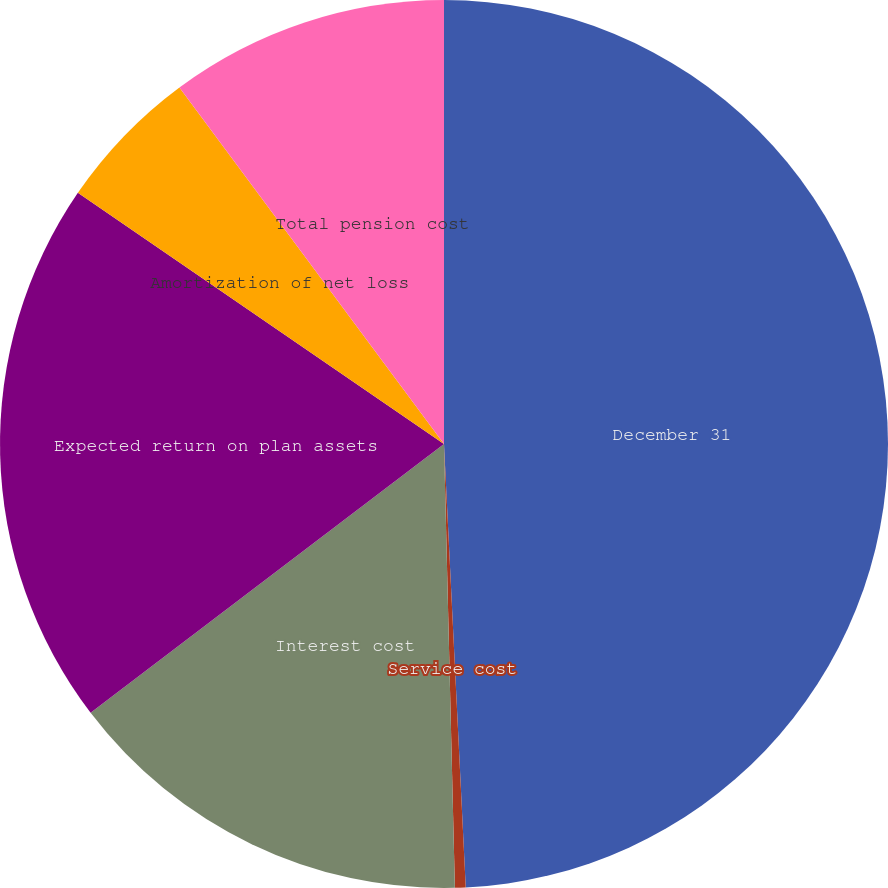Convert chart to OTSL. <chart><loc_0><loc_0><loc_500><loc_500><pie_chart><fcel>December 31<fcel>Service cost<fcel>Interest cost<fcel>Expected return on plan assets<fcel>Amortization of net loss<fcel>Total pension cost<nl><fcel>49.22%<fcel>0.39%<fcel>15.04%<fcel>19.92%<fcel>5.27%<fcel>10.16%<nl></chart> 